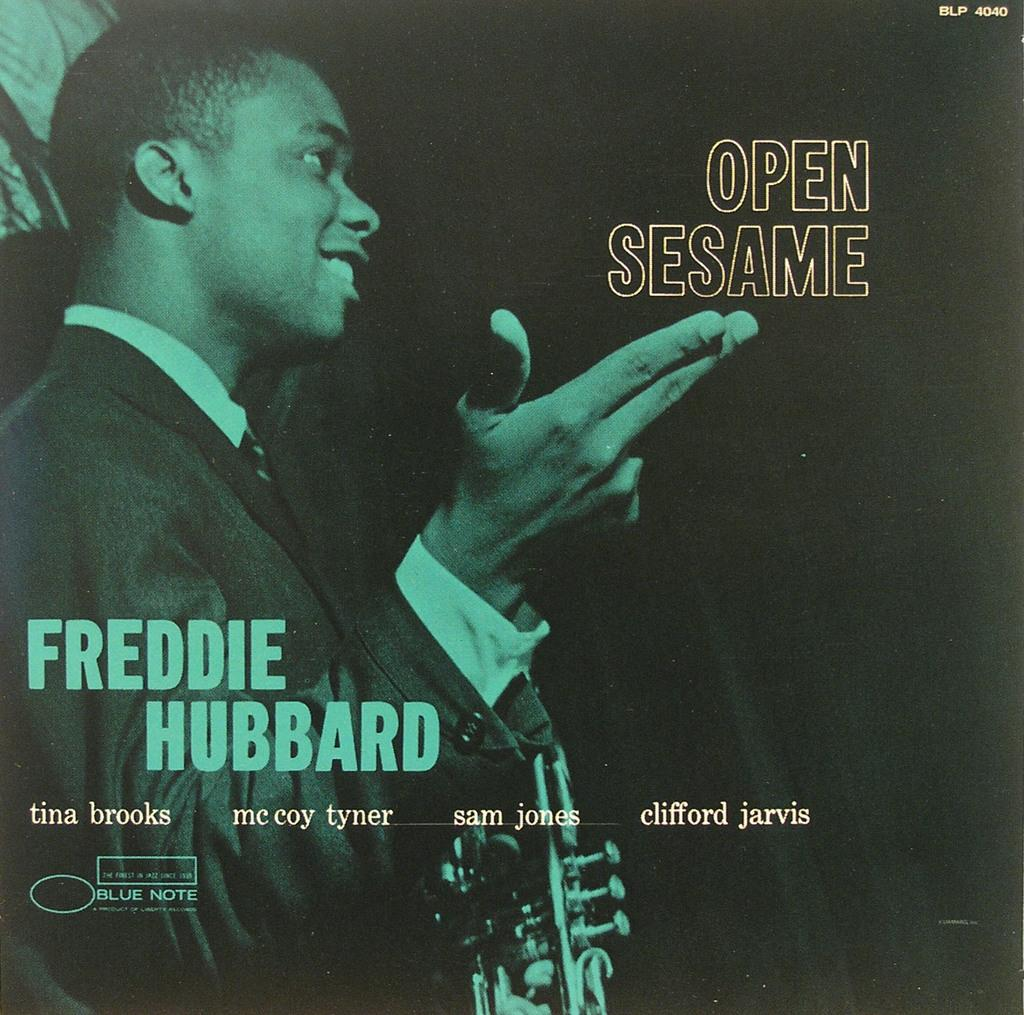<image>
Present a compact description of the photo's key features. Open sesame by Freddie Hubbard blue note album 